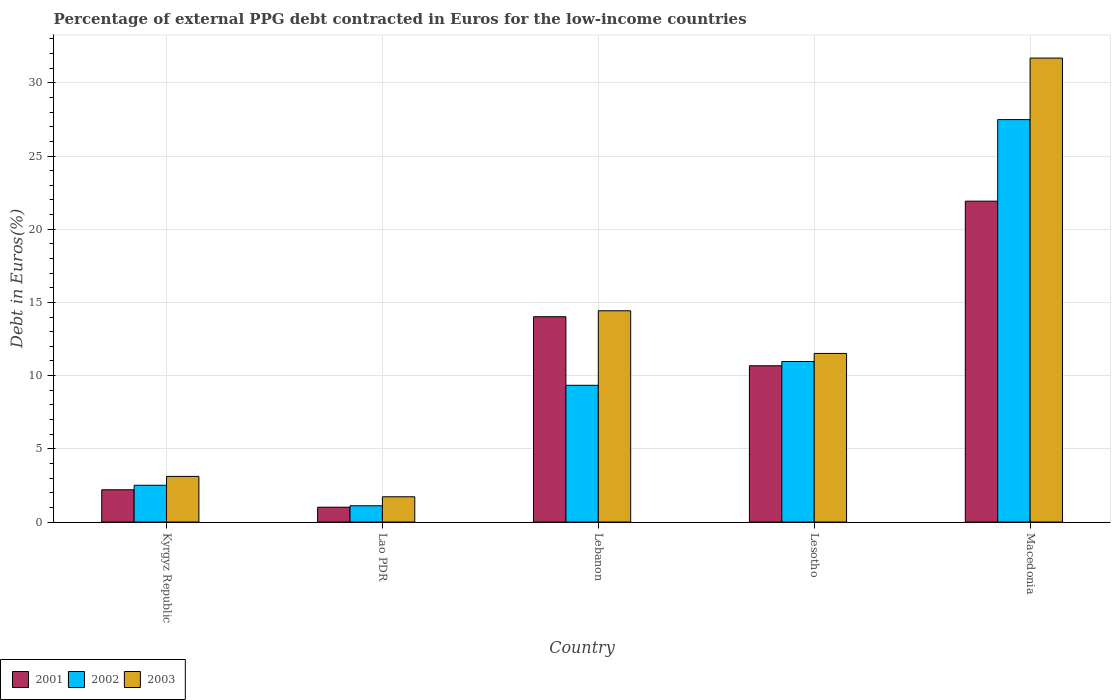How many groups of bars are there?
Keep it short and to the point. 5. How many bars are there on the 1st tick from the left?
Your response must be concise. 3. How many bars are there on the 5th tick from the right?
Make the answer very short. 3. What is the label of the 3rd group of bars from the left?
Your answer should be compact. Lebanon. What is the percentage of external PPG debt contracted in Euros in 2001 in Lebanon?
Provide a succinct answer. 14.02. Across all countries, what is the maximum percentage of external PPG debt contracted in Euros in 2002?
Ensure brevity in your answer.  27.49. Across all countries, what is the minimum percentage of external PPG debt contracted in Euros in 2001?
Your answer should be very brief. 1.01. In which country was the percentage of external PPG debt contracted in Euros in 2002 maximum?
Keep it short and to the point. Macedonia. In which country was the percentage of external PPG debt contracted in Euros in 2002 minimum?
Give a very brief answer. Lao PDR. What is the total percentage of external PPG debt contracted in Euros in 2002 in the graph?
Provide a short and direct response. 51.41. What is the difference between the percentage of external PPG debt contracted in Euros in 2003 in Lebanon and that in Lesotho?
Ensure brevity in your answer.  2.91. What is the difference between the percentage of external PPG debt contracted in Euros in 2002 in Kyrgyz Republic and the percentage of external PPG debt contracted in Euros in 2003 in Lebanon?
Your response must be concise. -11.92. What is the average percentage of external PPG debt contracted in Euros in 2003 per country?
Offer a terse response. 12.5. What is the difference between the percentage of external PPG debt contracted in Euros of/in 2003 and percentage of external PPG debt contracted in Euros of/in 2002 in Kyrgyz Republic?
Your response must be concise. 0.61. What is the ratio of the percentage of external PPG debt contracted in Euros in 2001 in Kyrgyz Republic to that in Lebanon?
Provide a succinct answer. 0.16. Is the difference between the percentage of external PPG debt contracted in Euros in 2003 in Kyrgyz Republic and Macedonia greater than the difference between the percentage of external PPG debt contracted in Euros in 2002 in Kyrgyz Republic and Macedonia?
Your answer should be very brief. No. What is the difference between the highest and the second highest percentage of external PPG debt contracted in Euros in 2002?
Keep it short and to the point. -1.63. What is the difference between the highest and the lowest percentage of external PPG debt contracted in Euros in 2003?
Keep it short and to the point. 29.96. In how many countries, is the percentage of external PPG debt contracted in Euros in 2001 greater than the average percentage of external PPG debt contracted in Euros in 2001 taken over all countries?
Give a very brief answer. 3. Is the sum of the percentage of external PPG debt contracted in Euros in 2001 in Lebanon and Lesotho greater than the maximum percentage of external PPG debt contracted in Euros in 2003 across all countries?
Provide a short and direct response. No. Is it the case that in every country, the sum of the percentage of external PPG debt contracted in Euros in 2003 and percentage of external PPG debt contracted in Euros in 2002 is greater than the percentage of external PPG debt contracted in Euros in 2001?
Keep it short and to the point. Yes. How many countries are there in the graph?
Provide a succinct answer. 5. What is the difference between two consecutive major ticks on the Y-axis?
Provide a short and direct response. 5. Are the values on the major ticks of Y-axis written in scientific E-notation?
Offer a very short reply. No. Does the graph contain any zero values?
Your answer should be very brief. No. Does the graph contain grids?
Your response must be concise. Yes. Where does the legend appear in the graph?
Keep it short and to the point. Bottom left. How are the legend labels stacked?
Make the answer very short. Horizontal. What is the title of the graph?
Your answer should be compact. Percentage of external PPG debt contracted in Euros for the low-income countries. What is the label or title of the Y-axis?
Offer a very short reply. Debt in Euros(%). What is the Debt in Euros(%) in 2001 in Kyrgyz Republic?
Your answer should be very brief. 2.2. What is the Debt in Euros(%) of 2002 in Kyrgyz Republic?
Offer a terse response. 2.51. What is the Debt in Euros(%) of 2003 in Kyrgyz Republic?
Your response must be concise. 3.12. What is the Debt in Euros(%) of 2001 in Lao PDR?
Make the answer very short. 1.01. What is the Debt in Euros(%) of 2002 in Lao PDR?
Provide a succinct answer. 1.11. What is the Debt in Euros(%) in 2003 in Lao PDR?
Provide a succinct answer. 1.73. What is the Debt in Euros(%) in 2001 in Lebanon?
Keep it short and to the point. 14.02. What is the Debt in Euros(%) in 2002 in Lebanon?
Your answer should be very brief. 9.34. What is the Debt in Euros(%) of 2003 in Lebanon?
Keep it short and to the point. 14.43. What is the Debt in Euros(%) in 2001 in Lesotho?
Your answer should be compact. 10.67. What is the Debt in Euros(%) of 2002 in Lesotho?
Offer a terse response. 10.96. What is the Debt in Euros(%) of 2003 in Lesotho?
Give a very brief answer. 11.52. What is the Debt in Euros(%) of 2001 in Macedonia?
Make the answer very short. 21.92. What is the Debt in Euros(%) of 2002 in Macedonia?
Your answer should be very brief. 27.49. What is the Debt in Euros(%) of 2003 in Macedonia?
Offer a terse response. 31.69. Across all countries, what is the maximum Debt in Euros(%) of 2001?
Give a very brief answer. 21.92. Across all countries, what is the maximum Debt in Euros(%) of 2002?
Your response must be concise. 27.49. Across all countries, what is the maximum Debt in Euros(%) in 2003?
Your answer should be compact. 31.69. Across all countries, what is the minimum Debt in Euros(%) of 2001?
Provide a succinct answer. 1.01. Across all countries, what is the minimum Debt in Euros(%) in 2002?
Make the answer very short. 1.11. Across all countries, what is the minimum Debt in Euros(%) in 2003?
Offer a very short reply. 1.73. What is the total Debt in Euros(%) in 2001 in the graph?
Make the answer very short. 49.83. What is the total Debt in Euros(%) in 2002 in the graph?
Offer a terse response. 51.41. What is the total Debt in Euros(%) in 2003 in the graph?
Keep it short and to the point. 62.48. What is the difference between the Debt in Euros(%) of 2001 in Kyrgyz Republic and that in Lao PDR?
Ensure brevity in your answer.  1.19. What is the difference between the Debt in Euros(%) in 2002 in Kyrgyz Republic and that in Lao PDR?
Offer a very short reply. 1.4. What is the difference between the Debt in Euros(%) of 2003 in Kyrgyz Republic and that in Lao PDR?
Keep it short and to the point. 1.39. What is the difference between the Debt in Euros(%) in 2001 in Kyrgyz Republic and that in Lebanon?
Make the answer very short. -11.82. What is the difference between the Debt in Euros(%) in 2002 in Kyrgyz Republic and that in Lebanon?
Ensure brevity in your answer.  -6.83. What is the difference between the Debt in Euros(%) in 2003 in Kyrgyz Republic and that in Lebanon?
Make the answer very short. -11.31. What is the difference between the Debt in Euros(%) in 2001 in Kyrgyz Republic and that in Lesotho?
Offer a terse response. -8.47. What is the difference between the Debt in Euros(%) of 2002 in Kyrgyz Republic and that in Lesotho?
Give a very brief answer. -8.45. What is the difference between the Debt in Euros(%) of 2003 in Kyrgyz Republic and that in Lesotho?
Provide a short and direct response. -8.4. What is the difference between the Debt in Euros(%) of 2001 in Kyrgyz Republic and that in Macedonia?
Your answer should be compact. -19.71. What is the difference between the Debt in Euros(%) in 2002 in Kyrgyz Republic and that in Macedonia?
Keep it short and to the point. -24.98. What is the difference between the Debt in Euros(%) of 2003 in Kyrgyz Republic and that in Macedonia?
Offer a very short reply. -28.57. What is the difference between the Debt in Euros(%) of 2001 in Lao PDR and that in Lebanon?
Your answer should be very brief. -13.01. What is the difference between the Debt in Euros(%) in 2002 in Lao PDR and that in Lebanon?
Your answer should be very brief. -8.23. What is the difference between the Debt in Euros(%) of 2003 in Lao PDR and that in Lebanon?
Offer a terse response. -12.7. What is the difference between the Debt in Euros(%) of 2001 in Lao PDR and that in Lesotho?
Your answer should be very brief. -9.66. What is the difference between the Debt in Euros(%) in 2002 in Lao PDR and that in Lesotho?
Ensure brevity in your answer.  -9.85. What is the difference between the Debt in Euros(%) in 2003 in Lao PDR and that in Lesotho?
Keep it short and to the point. -9.79. What is the difference between the Debt in Euros(%) of 2001 in Lao PDR and that in Macedonia?
Make the answer very short. -20.9. What is the difference between the Debt in Euros(%) in 2002 in Lao PDR and that in Macedonia?
Keep it short and to the point. -26.38. What is the difference between the Debt in Euros(%) of 2003 in Lao PDR and that in Macedonia?
Offer a very short reply. -29.96. What is the difference between the Debt in Euros(%) of 2001 in Lebanon and that in Lesotho?
Keep it short and to the point. 3.35. What is the difference between the Debt in Euros(%) in 2002 in Lebanon and that in Lesotho?
Provide a succinct answer. -1.63. What is the difference between the Debt in Euros(%) of 2003 in Lebanon and that in Lesotho?
Provide a succinct answer. 2.91. What is the difference between the Debt in Euros(%) in 2001 in Lebanon and that in Macedonia?
Provide a succinct answer. -7.89. What is the difference between the Debt in Euros(%) in 2002 in Lebanon and that in Macedonia?
Ensure brevity in your answer.  -18.15. What is the difference between the Debt in Euros(%) in 2003 in Lebanon and that in Macedonia?
Make the answer very short. -17.26. What is the difference between the Debt in Euros(%) in 2001 in Lesotho and that in Macedonia?
Offer a terse response. -11.24. What is the difference between the Debt in Euros(%) in 2002 in Lesotho and that in Macedonia?
Provide a short and direct response. -16.52. What is the difference between the Debt in Euros(%) in 2003 in Lesotho and that in Macedonia?
Make the answer very short. -20.17. What is the difference between the Debt in Euros(%) in 2001 in Kyrgyz Republic and the Debt in Euros(%) in 2002 in Lao PDR?
Give a very brief answer. 1.09. What is the difference between the Debt in Euros(%) of 2001 in Kyrgyz Republic and the Debt in Euros(%) of 2003 in Lao PDR?
Ensure brevity in your answer.  0.48. What is the difference between the Debt in Euros(%) of 2002 in Kyrgyz Republic and the Debt in Euros(%) of 2003 in Lao PDR?
Ensure brevity in your answer.  0.79. What is the difference between the Debt in Euros(%) in 2001 in Kyrgyz Republic and the Debt in Euros(%) in 2002 in Lebanon?
Offer a terse response. -7.14. What is the difference between the Debt in Euros(%) in 2001 in Kyrgyz Republic and the Debt in Euros(%) in 2003 in Lebanon?
Your response must be concise. -12.23. What is the difference between the Debt in Euros(%) in 2002 in Kyrgyz Republic and the Debt in Euros(%) in 2003 in Lebanon?
Your answer should be very brief. -11.92. What is the difference between the Debt in Euros(%) of 2001 in Kyrgyz Republic and the Debt in Euros(%) of 2002 in Lesotho?
Keep it short and to the point. -8.76. What is the difference between the Debt in Euros(%) in 2001 in Kyrgyz Republic and the Debt in Euros(%) in 2003 in Lesotho?
Your response must be concise. -9.31. What is the difference between the Debt in Euros(%) in 2002 in Kyrgyz Republic and the Debt in Euros(%) in 2003 in Lesotho?
Offer a terse response. -9.01. What is the difference between the Debt in Euros(%) of 2001 in Kyrgyz Republic and the Debt in Euros(%) of 2002 in Macedonia?
Ensure brevity in your answer.  -25.28. What is the difference between the Debt in Euros(%) of 2001 in Kyrgyz Republic and the Debt in Euros(%) of 2003 in Macedonia?
Give a very brief answer. -29.49. What is the difference between the Debt in Euros(%) in 2002 in Kyrgyz Republic and the Debt in Euros(%) in 2003 in Macedonia?
Provide a succinct answer. -29.18. What is the difference between the Debt in Euros(%) in 2001 in Lao PDR and the Debt in Euros(%) in 2002 in Lebanon?
Give a very brief answer. -8.33. What is the difference between the Debt in Euros(%) of 2001 in Lao PDR and the Debt in Euros(%) of 2003 in Lebanon?
Your answer should be compact. -13.42. What is the difference between the Debt in Euros(%) of 2002 in Lao PDR and the Debt in Euros(%) of 2003 in Lebanon?
Provide a succinct answer. -13.32. What is the difference between the Debt in Euros(%) in 2001 in Lao PDR and the Debt in Euros(%) in 2002 in Lesotho?
Keep it short and to the point. -9.95. What is the difference between the Debt in Euros(%) in 2001 in Lao PDR and the Debt in Euros(%) in 2003 in Lesotho?
Your response must be concise. -10.5. What is the difference between the Debt in Euros(%) of 2002 in Lao PDR and the Debt in Euros(%) of 2003 in Lesotho?
Offer a very short reply. -10.41. What is the difference between the Debt in Euros(%) in 2001 in Lao PDR and the Debt in Euros(%) in 2002 in Macedonia?
Your answer should be compact. -26.47. What is the difference between the Debt in Euros(%) in 2001 in Lao PDR and the Debt in Euros(%) in 2003 in Macedonia?
Offer a very short reply. -30.68. What is the difference between the Debt in Euros(%) of 2002 in Lao PDR and the Debt in Euros(%) of 2003 in Macedonia?
Offer a terse response. -30.58. What is the difference between the Debt in Euros(%) in 2001 in Lebanon and the Debt in Euros(%) in 2002 in Lesotho?
Ensure brevity in your answer.  3.06. What is the difference between the Debt in Euros(%) of 2001 in Lebanon and the Debt in Euros(%) of 2003 in Lesotho?
Keep it short and to the point. 2.51. What is the difference between the Debt in Euros(%) in 2002 in Lebanon and the Debt in Euros(%) in 2003 in Lesotho?
Provide a succinct answer. -2.18. What is the difference between the Debt in Euros(%) of 2001 in Lebanon and the Debt in Euros(%) of 2002 in Macedonia?
Make the answer very short. -13.46. What is the difference between the Debt in Euros(%) in 2001 in Lebanon and the Debt in Euros(%) in 2003 in Macedonia?
Offer a very short reply. -17.67. What is the difference between the Debt in Euros(%) in 2002 in Lebanon and the Debt in Euros(%) in 2003 in Macedonia?
Offer a terse response. -22.35. What is the difference between the Debt in Euros(%) of 2001 in Lesotho and the Debt in Euros(%) of 2002 in Macedonia?
Give a very brief answer. -16.81. What is the difference between the Debt in Euros(%) of 2001 in Lesotho and the Debt in Euros(%) of 2003 in Macedonia?
Your response must be concise. -21.02. What is the difference between the Debt in Euros(%) of 2002 in Lesotho and the Debt in Euros(%) of 2003 in Macedonia?
Give a very brief answer. -20.73. What is the average Debt in Euros(%) in 2001 per country?
Ensure brevity in your answer.  9.97. What is the average Debt in Euros(%) in 2002 per country?
Ensure brevity in your answer.  10.28. What is the average Debt in Euros(%) of 2003 per country?
Your answer should be compact. 12.5. What is the difference between the Debt in Euros(%) in 2001 and Debt in Euros(%) in 2002 in Kyrgyz Republic?
Offer a terse response. -0.31. What is the difference between the Debt in Euros(%) of 2001 and Debt in Euros(%) of 2003 in Kyrgyz Republic?
Make the answer very short. -0.91. What is the difference between the Debt in Euros(%) of 2002 and Debt in Euros(%) of 2003 in Kyrgyz Republic?
Offer a very short reply. -0.61. What is the difference between the Debt in Euros(%) in 2001 and Debt in Euros(%) in 2002 in Lao PDR?
Give a very brief answer. -0.1. What is the difference between the Debt in Euros(%) of 2001 and Debt in Euros(%) of 2003 in Lao PDR?
Your response must be concise. -0.71. What is the difference between the Debt in Euros(%) in 2002 and Debt in Euros(%) in 2003 in Lao PDR?
Provide a short and direct response. -0.61. What is the difference between the Debt in Euros(%) in 2001 and Debt in Euros(%) in 2002 in Lebanon?
Ensure brevity in your answer.  4.68. What is the difference between the Debt in Euros(%) in 2001 and Debt in Euros(%) in 2003 in Lebanon?
Your answer should be compact. -0.41. What is the difference between the Debt in Euros(%) of 2002 and Debt in Euros(%) of 2003 in Lebanon?
Offer a very short reply. -5.09. What is the difference between the Debt in Euros(%) of 2001 and Debt in Euros(%) of 2002 in Lesotho?
Provide a short and direct response. -0.29. What is the difference between the Debt in Euros(%) in 2001 and Debt in Euros(%) in 2003 in Lesotho?
Keep it short and to the point. -0.84. What is the difference between the Debt in Euros(%) of 2002 and Debt in Euros(%) of 2003 in Lesotho?
Provide a short and direct response. -0.55. What is the difference between the Debt in Euros(%) of 2001 and Debt in Euros(%) of 2002 in Macedonia?
Offer a very short reply. -5.57. What is the difference between the Debt in Euros(%) of 2001 and Debt in Euros(%) of 2003 in Macedonia?
Your answer should be compact. -9.77. What is the difference between the Debt in Euros(%) of 2002 and Debt in Euros(%) of 2003 in Macedonia?
Make the answer very short. -4.2. What is the ratio of the Debt in Euros(%) in 2001 in Kyrgyz Republic to that in Lao PDR?
Give a very brief answer. 2.18. What is the ratio of the Debt in Euros(%) of 2002 in Kyrgyz Republic to that in Lao PDR?
Keep it short and to the point. 2.26. What is the ratio of the Debt in Euros(%) of 2003 in Kyrgyz Republic to that in Lao PDR?
Give a very brief answer. 1.81. What is the ratio of the Debt in Euros(%) of 2001 in Kyrgyz Republic to that in Lebanon?
Make the answer very short. 0.16. What is the ratio of the Debt in Euros(%) in 2002 in Kyrgyz Republic to that in Lebanon?
Your answer should be compact. 0.27. What is the ratio of the Debt in Euros(%) of 2003 in Kyrgyz Republic to that in Lebanon?
Give a very brief answer. 0.22. What is the ratio of the Debt in Euros(%) of 2001 in Kyrgyz Republic to that in Lesotho?
Provide a short and direct response. 0.21. What is the ratio of the Debt in Euros(%) in 2002 in Kyrgyz Republic to that in Lesotho?
Your answer should be compact. 0.23. What is the ratio of the Debt in Euros(%) of 2003 in Kyrgyz Republic to that in Lesotho?
Make the answer very short. 0.27. What is the ratio of the Debt in Euros(%) of 2001 in Kyrgyz Republic to that in Macedonia?
Offer a terse response. 0.1. What is the ratio of the Debt in Euros(%) of 2002 in Kyrgyz Republic to that in Macedonia?
Give a very brief answer. 0.09. What is the ratio of the Debt in Euros(%) in 2003 in Kyrgyz Republic to that in Macedonia?
Provide a succinct answer. 0.1. What is the ratio of the Debt in Euros(%) of 2001 in Lao PDR to that in Lebanon?
Offer a terse response. 0.07. What is the ratio of the Debt in Euros(%) of 2002 in Lao PDR to that in Lebanon?
Your answer should be very brief. 0.12. What is the ratio of the Debt in Euros(%) in 2003 in Lao PDR to that in Lebanon?
Provide a short and direct response. 0.12. What is the ratio of the Debt in Euros(%) of 2001 in Lao PDR to that in Lesotho?
Give a very brief answer. 0.09. What is the ratio of the Debt in Euros(%) of 2002 in Lao PDR to that in Lesotho?
Make the answer very short. 0.1. What is the ratio of the Debt in Euros(%) of 2003 in Lao PDR to that in Lesotho?
Keep it short and to the point. 0.15. What is the ratio of the Debt in Euros(%) in 2001 in Lao PDR to that in Macedonia?
Your answer should be very brief. 0.05. What is the ratio of the Debt in Euros(%) in 2002 in Lao PDR to that in Macedonia?
Your answer should be very brief. 0.04. What is the ratio of the Debt in Euros(%) in 2003 in Lao PDR to that in Macedonia?
Give a very brief answer. 0.05. What is the ratio of the Debt in Euros(%) in 2001 in Lebanon to that in Lesotho?
Offer a very short reply. 1.31. What is the ratio of the Debt in Euros(%) of 2002 in Lebanon to that in Lesotho?
Provide a short and direct response. 0.85. What is the ratio of the Debt in Euros(%) of 2003 in Lebanon to that in Lesotho?
Make the answer very short. 1.25. What is the ratio of the Debt in Euros(%) in 2001 in Lebanon to that in Macedonia?
Offer a very short reply. 0.64. What is the ratio of the Debt in Euros(%) in 2002 in Lebanon to that in Macedonia?
Your answer should be very brief. 0.34. What is the ratio of the Debt in Euros(%) in 2003 in Lebanon to that in Macedonia?
Provide a succinct answer. 0.46. What is the ratio of the Debt in Euros(%) of 2001 in Lesotho to that in Macedonia?
Make the answer very short. 0.49. What is the ratio of the Debt in Euros(%) in 2002 in Lesotho to that in Macedonia?
Give a very brief answer. 0.4. What is the ratio of the Debt in Euros(%) of 2003 in Lesotho to that in Macedonia?
Your answer should be very brief. 0.36. What is the difference between the highest and the second highest Debt in Euros(%) of 2001?
Your answer should be compact. 7.89. What is the difference between the highest and the second highest Debt in Euros(%) of 2002?
Ensure brevity in your answer.  16.52. What is the difference between the highest and the second highest Debt in Euros(%) in 2003?
Your response must be concise. 17.26. What is the difference between the highest and the lowest Debt in Euros(%) in 2001?
Ensure brevity in your answer.  20.9. What is the difference between the highest and the lowest Debt in Euros(%) in 2002?
Provide a short and direct response. 26.38. What is the difference between the highest and the lowest Debt in Euros(%) of 2003?
Offer a terse response. 29.96. 